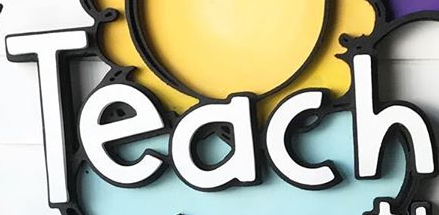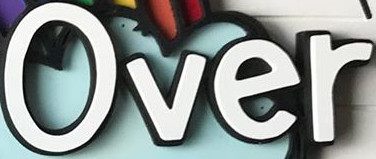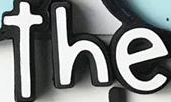Transcribe the words shown in these images in order, separated by a semicolon. Teach; Over; the 